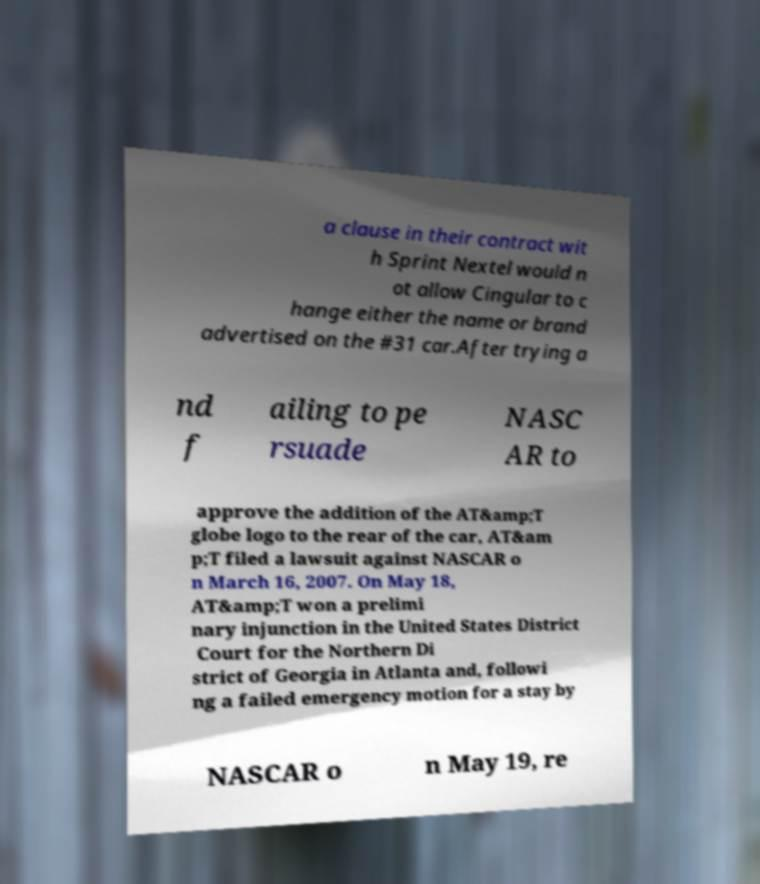Please identify and transcribe the text found in this image. a clause in their contract wit h Sprint Nextel would n ot allow Cingular to c hange either the name or brand advertised on the #31 car.After trying a nd f ailing to pe rsuade NASC AR to approve the addition of the AT&amp;T globe logo to the rear of the car, AT&am p;T filed a lawsuit against NASCAR o n March 16, 2007. On May 18, AT&amp;T won a prelimi nary injunction in the United States District Court for the Northern Di strict of Georgia in Atlanta and, followi ng a failed emergency motion for a stay by NASCAR o n May 19, re 